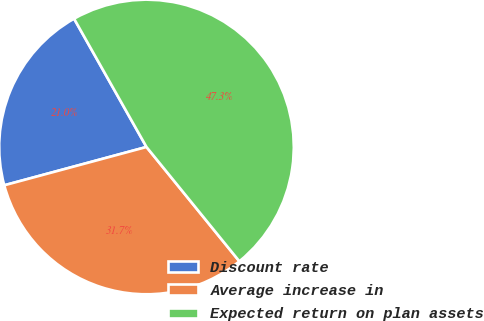<chart> <loc_0><loc_0><loc_500><loc_500><pie_chart><fcel>Discount rate<fcel>Average increase in<fcel>Expected return on plan assets<nl><fcel>21.01%<fcel>31.67%<fcel>47.32%<nl></chart> 